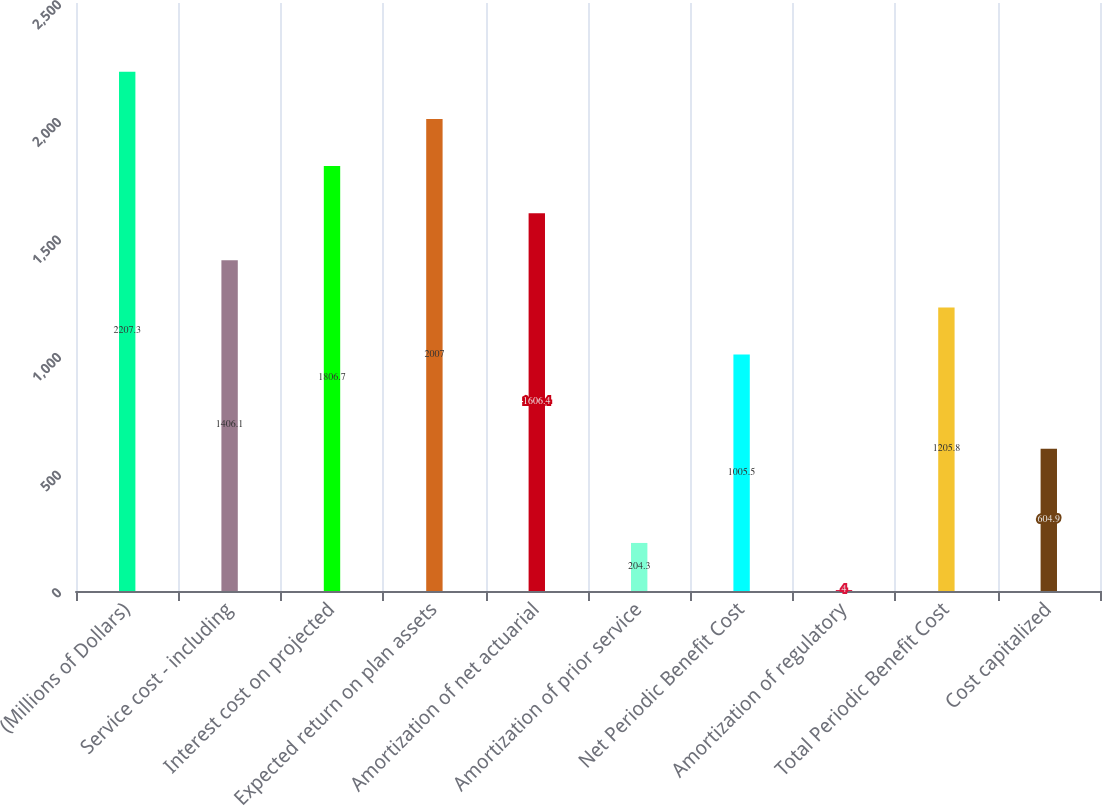Convert chart to OTSL. <chart><loc_0><loc_0><loc_500><loc_500><bar_chart><fcel>(Millions of Dollars)<fcel>Service cost - including<fcel>Interest cost on projected<fcel>Expected return on plan assets<fcel>Amortization of net actuarial<fcel>Amortization of prior service<fcel>Net Periodic Benefit Cost<fcel>Amortization of regulatory<fcel>Total Periodic Benefit Cost<fcel>Cost capitalized<nl><fcel>2207.3<fcel>1406.1<fcel>1806.7<fcel>2007<fcel>1606.4<fcel>204.3<fcel>1005.5<fcel>4<fcel>1205.8<fcel>604.9<nl></chart> 